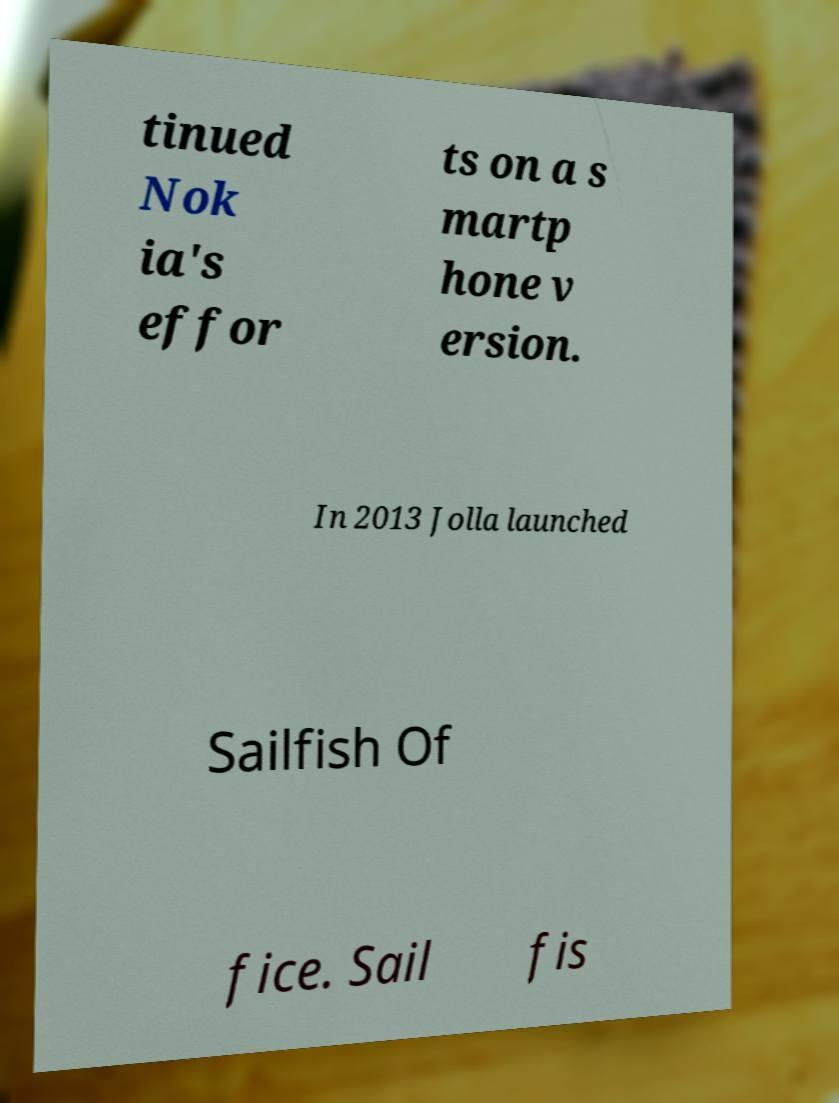I need the written content from this picture converted into text. Can you do that? tinued Nok ia's effor ts on a s martp hone v ersion. In 2013 Jolla launched Sailfish Of fice. Sail fis 